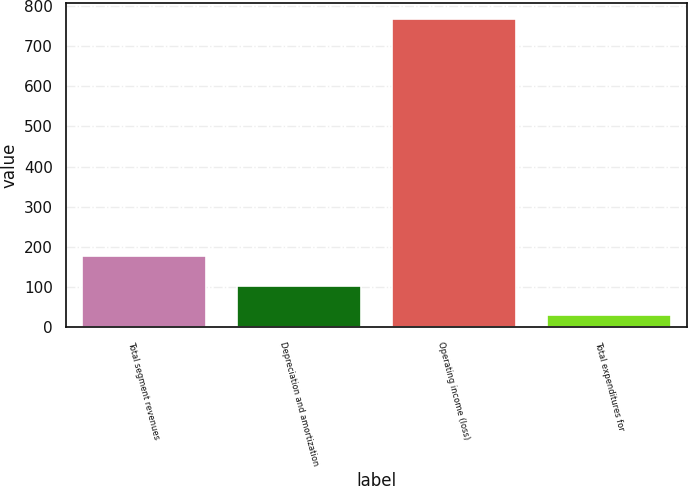Convert chart to OTSL. <chart><loc_0><loc_0><loc_500><loc_500><bar_chart><fcel>Total segment revenues<fcel>Depreciation and amortization<fcel>Operating income (loss)<fcel>Total expenditures for<nl><fcel>177.6<fcel>103.8<fcel>768<fcel>30<nl></chart> 